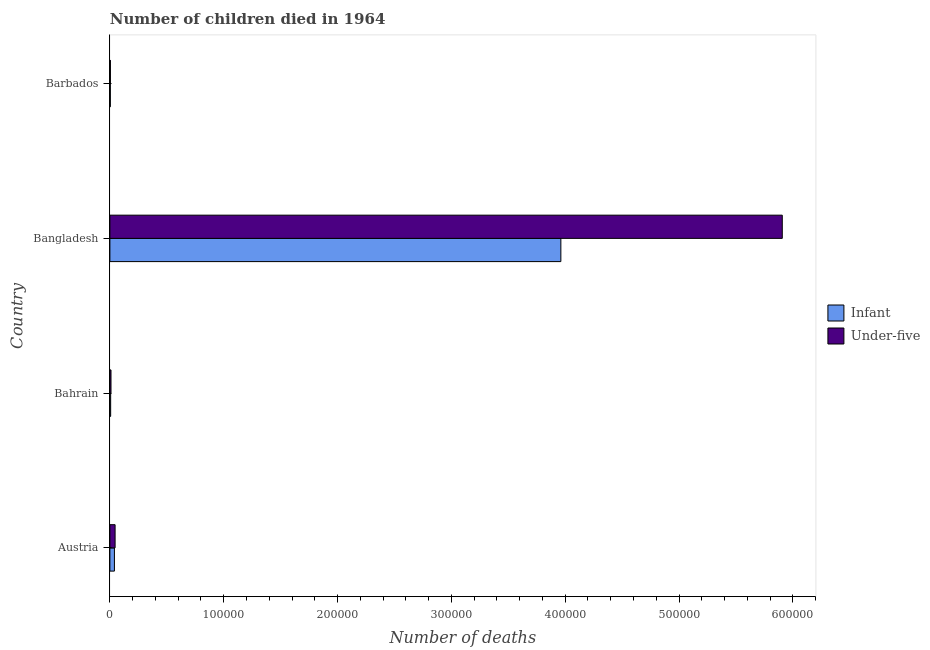How many different coloured bars are there?
Offer a terse response. 2. How many groups of bars are there?
Provide a succinct answer. 4. Are the number of bars per tick equal to the number of legend labels?
Offer a very short reply. Yes. What is the label of the 2nd group of bars from the top?
Offer a very short reply. Bangladesh. In how many cases, is the number of bars for a given country not equal to the number of legend labels?
Offer a terse response. 0. What is the number of under-five deaths in Austria?
Keep it short and to the point. 4577. Across all countries, what is the maximum number of infant deaths?
Give a very brief answer. 3.96e+05. Across all countries, what is the minimum number of under-five deaths?
Offer a terse response. 456. In which country was the number of infant deaths minimum?
Keep it short and to the point. Barbados. What is the total number of infant deaths in the graph?
Provide a succinct answer. 4.01e+05. What is the difference between the number of under-five deaths in Bangladesh and that in Barbados?
Give a very brief answer. 5.90e+05. What is the difference between the number of infant deaths in Bangladesh and the number of under-five deaths in Barbados?
Make the answer very short. 3.96e+05. What is the average number of under-five deaths per country?
Your answer should be very brief. 1.49e+05. What is the difference between the number of infant deaths and number of under-five deaths in Austria?
Give a very brief answer. -593. In how many countries, is the number of infant deaths greater than 560000 ?
Offer a terse response. 0. What is the ratio of the number of infant deaths in Bangladesh to that in Barbados?
Provide a succinct answer. 1031.71. Is the number of under-five deaths in Austria less than that in Bangladesh?
Keep it short and to the point. Yes. Is the difference between the number of under-five deaths in Bangladesh and Barbados greater than the difference between the number of infant deaths in Bangladesh and Barbados?
Provide a short and direct response. Yes. What is the difference between the highest and the second highest number of infant deaths?
Your answer should be compact. 3.92e+05. What is the difference between the highest and the lowest number of infant deaths?
Offer a very short reply. 3.96e+05. In how many countries, is the number of under-five deaths greater than the average number of under-five deaths taken over all countries?
Provide a short and direct response. 1. Is the sum of the number of infant deaths in Austria and Barbados greater than the maximum number of under-five deaths across all countries?
Your response must be concise. No. What does the 1st bar from the top in Barbados represents?
Offer a terse response. Under-five. What does the 1st bar from the bottom in Bangladesh represents?
Ensure brevity in your answer.  Infant. How many countries are there in the graph?
Your answer should be compact. 4. What is the difference between two consecutive major ticks on the X-axis?
Keep it short and to the point. 1.00e+05. Does the graph contain grids?
Ensure brevity in your answer.  No. How are the legend labels stacked?
Make the answer very short. Vertical. What is the title of the graph?
Offer a terse response. Number of children died in 1964. What is the label or title of the X-axis?
Give a very brief answer. Number of deaths. What is the label or title of the Y-axis?
Provide a succinct answer. Country. What is the Number of deaths of Infant in Austria?
Make the answer very short. 3984. What is the Number of deaths of Under-five in Austria?
Provide a short and direct response. 4577. What is the Number of deaths of Infant in Bahrain?
Keep it short and to the point. 671. What is the Number of deaths of Under-five in Bahrain?
Your answer should be compact. 971. What is the Number of deaths of Infant in Bangladesh?
Your answer should be compact. 3.96e+05. What is the Number of deaths in Under-five in Bangladesh?
Your answer should be compact. 5.91e+05. What is the Number of deaths in Infant in Barbados?
Your response must be concise. 384. What is the Number of deaths of Under-five in Barbados?
Offer a terse response. 456. Across all countries, what is the maximum Number of deaths in Infant?
Provide a succinct answer. 3.96e+05. Across all countries, what is the maximum Number of deaths in Under-five?
Give a very brief answer. 5.91e+05. Across all countries, what is the minimum Number of deaths in Infant?
Your response must be concise. 384. Across all countries, what is the minimum Number of deaths of Under-five?
Your answer should be compact. 456. What is the total Number of deaths of Infant in the graph?
Provide a succinct answer. 4.01e+05. What is the total Number of deaths in Under-five in the graph?
Make the answer very short. 5.97e+05. What is the difference between the Number of deaths of Infant in Austria and that in Bahrain?
Make the answer very short. 3313. What is the difference between the Number of deaths in Under-five in Austria and that in Bahrain?
Make the answer very short. 3606. What is the difference between the Number of deaths of Infant in Austria and that in Bangladesh?
Give a very brief answer. -3.92e+05. What is the difference between the Number of deaths in Under-five in Austria and that in Bangladesh?
Your response must be concise. -5.86e+05. What is the difference between the Number of deaths in Infant in Austria and that in Barbados?
Ensure brevity in your answer.  3600. What is the difference between the Number of deaths in Under-five in Austria and that in Barbados?
Make the answer very short. 4121. What is the difference between the Number of deaths in Infant in Bahrain and that in Bangladesh?
Keep it short and to the point. -3.96e+05. What is the difference between the Number of deaths of Under-five in Bahrain and that in Bangladesh?
Offer a terse response. -5.90e+05. What is the difference between the Number of deaths in Infant in Bahrain and that in Barbados?
Offer a terse response. 287. What is the difference between the Number of deaths in Under-five in Bahrain and that in Barbados?
Your answer should be compact. 515. What is the difference between the Number of deaths of Infant in Bangladesh and that in Barbados?
Keep it short and to the point. 3.96e+05. What is the difference between the Number of deaths of Under-five in Bangladesh and that in Barbados?
Your answer should be very brief. 5.90e+05. What is the difference between the Number of deaths in Infant in Austria and the Number of deaths in Under-five in Bahrain?
Offer a very short reply. 3013. What is the difference between the Number of deaths in Infant in Austria and the Number of deaths in Under-five in Bangladesh?
Your answer should be compact. -5.87e+05. What is the difference between the Number of deaths of Infant in Austria and the Number of deaths of Under-five in Barbados?
Your answer should be compact. 3528. What is the difference between the Number of deaths of Infant in Bahrain and the Number of deaths of Under-five in Bangladesh?
Keep it short and to the point. -5.90e+05. What is the difference between the Number of deaths of Infant in Bahrain and the Number of deaths of Under-five in Barbados?
Provide a succinct answer. 215. What is the difference between the Number of deaths of Infant in Bangladesh and the Number of deaths of Under-five in Barbados?
Your answer should be compact. 3.96e+05. What is the average Number of deaths of Infant per country?
Your response must be concise. 1.00e+05. What is the average Number of deaths in Under-five per country?
Ensure brevity in your answer.  1.49e+05. What is the difference between the Number of deaths in Infant and Number of deaths in Under-five in Austria?
Offer a very short reply. -593. What is the difference between the Number of deaths in Infant and Number of deaths in Under-five in Bahrain?
Give a very brief answer. -300. What is the difference between the Number of deaths of Infant and Number of deaths of Under-five in Bangladesh?
Ensure brevity in your answer.  -1.95e+05. What is the difference between the Number of deaths of Infant and Number of deaths of Under-five in Barbados?
Offer a terse response. -72. What is the ratio of the Number of deaths in Infant in Austria to that in Bahrain?
Provide a succinct answer. 5.94. What is the ratio of the Number of deaths of Under-five in Austria to that in Bahrain?
Offer a very short reply. 4.71. What is the ratio of the Number of deaths in Infant in Austria to that in Bangladesh?
Make the answer very short. 0.01. What is the ratio of the Number of deaths of Under-five in Austria to that in Bangladesh?
Ensure brevity in your answer.  0.01. What is the ratio of the Number of deaths in Infant in Austria to that in Barbados?
Your response must be concise. 10.38. What is the ratio of the Number of deaths in Under-five in Austria to that in Barbados?
Provide a short and direct response. 10.04. What is the ratio of the Number of deaths in Infant in Bahrain to that in Bangladesh?
Offer a very short reply. 0. What is the ratio of the Number of deaths in Under-five in Bahrain to that in Bangladesh?
Keep it short and to the point. 0. What is the ratio of the Number of deaths of Infant in Bahrain to that in Barbados?
Your answer should be compact. 1.75. What is the ratio of the Number of deaths of Under-five in Bahrain to that in Barbados?
Give a very brief answer. 2.13. What is the ratio of the Number of deaths in Infant in Bangladesh to that in Barbados?
Offer a very short reply. 1031.71. What is the ratio of the Number of deaths in Under-five in Bangladesh to that in Barbados?
Keep it short and to the point. 1295.39. What is the difference between the highest and the second highest Number of deaths in Infant?
Provide a short and direct response. 3.92e+05. What is the difference between the highest and the second highest Number of deaths in Under-five?
Your answer should be compact. 5.86e+05. What is the difference between the highest and the lowest Number of deaths in Infant?
Keep it short and to the point. 3.96e+05. What is the difference between the highest and the lowest Number of deaths of Under-five?
Ensure brevity in your answer.  5.90e+05. 